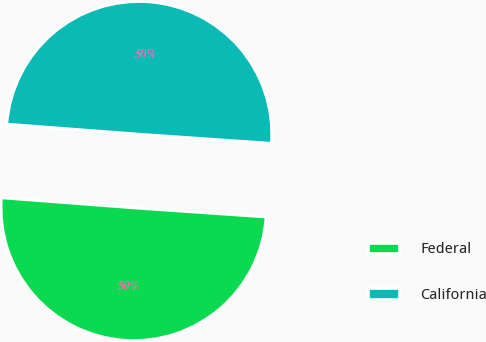<chart> <loc_0><loc_0><loc_500><loc_500><pie_chart><fcel>Federal<fcel>California<nl><fcel>50.11%<fcel>49.89%<nl></chart> 